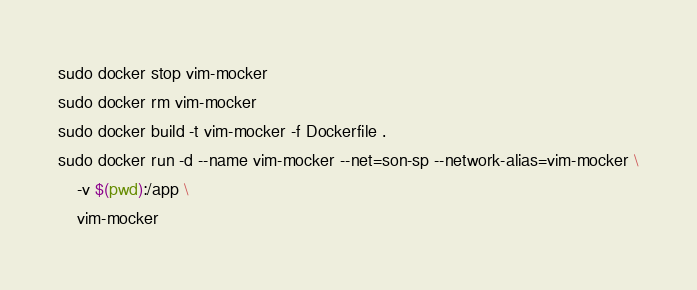<code> <loc_0><loc_0><loc_500><loc_500><_Bash_>sudo docker stop vim-mocker
sudo docker rm vim-mocker
sudo docker build -t vim-mocker -f Dockerfile .
sudo docker run -d --name vim-mocker --net=son-sp --network-alias=vim-mocker \
    -v $(pwd):/app \
    vim-mocker
</code> 